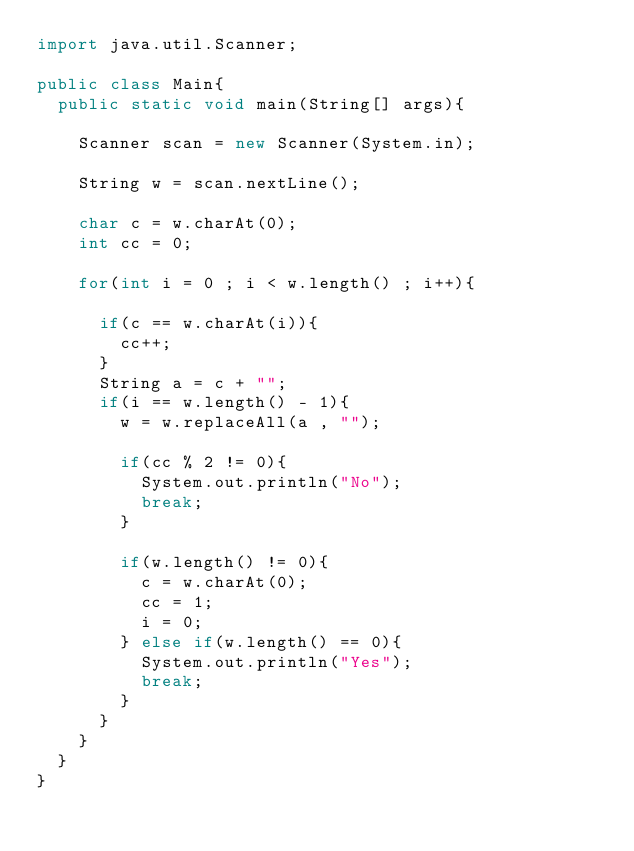<code> <loc_0><loc_0><loc_500><loc_500><_Java_>import java.util.Scanner;

public class Main{
	public static void main(String[] args){
		
		Scanner scan = new Scanner(System.in);
		
		String w = scan.nextLine();
		
		char c = w.charAt(0);
		int cc = 0;
		
		for(int i = 0 ; i < w.length() ; i++){
			
			if(c == w.charAt(i)){
				cc++;
			}
			String a = c + "";
			if(i == w.length() - 1){
				w = w.replaceAll(a , "");
				
				if(cc % 2 != 0){
					System.out.println("No");
					break;
				}
				
				if(w.length() != 0){
					c = w.charAt(0);
					cc = 1;
					i = 0;
				} else if(w.length() == 0){
					System.out.println("Yes");
					break;
				}
			}
		}
	}
}
</code> 